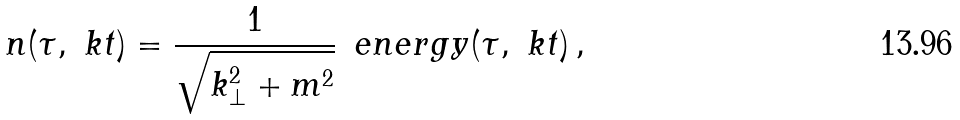<formula> <loc_0><loc_0><loc_500><loc_500>n ( \tau , \ k t ) = \frac { 1 } { \sqrt { k _ { \perp } ^ { 2 } + m ^ { 2 } } } \, \ e n e r g y ( \tau , \ k t ) \, ,</formula> 